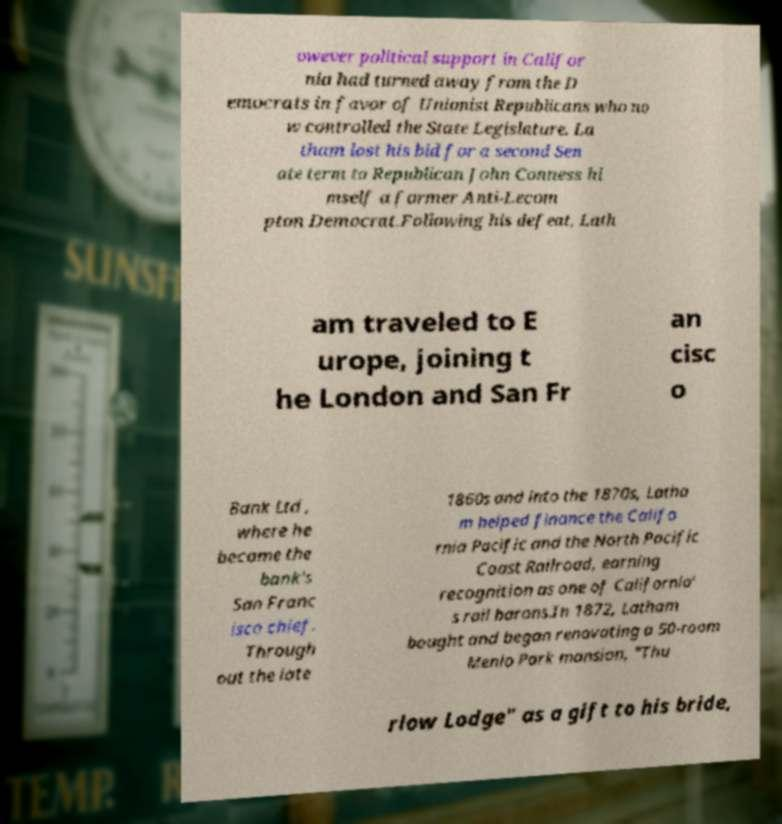Can you read and provide the text displayed in the image?This photo seems to have some interesting text. Can you extract and type it out for me? owever political support in Califor nia had turned away from the D emocrats in favor of Unionist Republicans who no w controlled the State Legislature. La tham lost his bid for a second Sen ate term to Republican John Conness hi mself a former Anti-Lecom pton Democrat.Following his defeat, Lath am traveled to E urope, joining t he London and San Fr an cisc o Bank Ltd , where he became the bank's San Franc isco chief. Through out the late 1860s and into the 1870s, Latha m helped finance the Califo rnia Pacific and the North Pacific Coast Railroad, earning recognition as one of California' s rail barons.In 1872, Latham bought and began renovating a 50-room Menlo Park mansion, "Thu rlow Lodge" as a gift to his bride, 